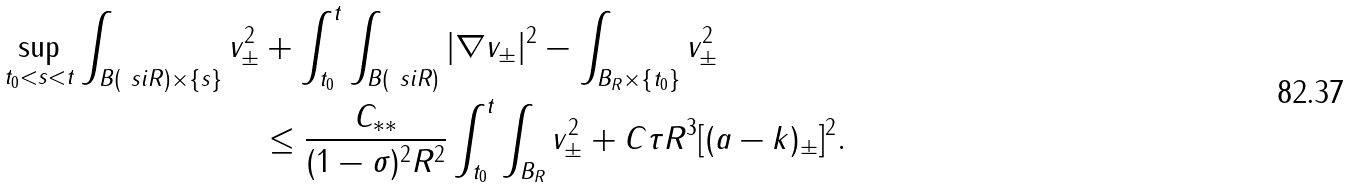Convert formula to latex. <formula><loc_0><loc_0><loc_500><loc_500>\sup _ { t _ { 0 } < s < t } \int _ { B ( \ s i R ) \times \{ s \} } v ^ { 2 } _ { \pm } & + \int _ { t _ { 0 } } ^ { t } \int _ { B ( \ s i R ) } | \nabla v _ { \pm } | ^ { 2 } - \int _ { B _ { R } \times \{ t _ { 0 } \} } v _ { \pm } ^ { 2 } \\ & \leq \frac { C _ { * * } } { ( 1 - \sigma ) ^ { 2 } R ^ { 2 } } \int _ { t _ { 0 } } ^ { t } \int _ { B _ { R } } v _ { \pm } ^ { 2 } + C \tau R ^ { 3 } [ ( a - k ) _ { \pm } ] ^ { 2 } .</formula> 